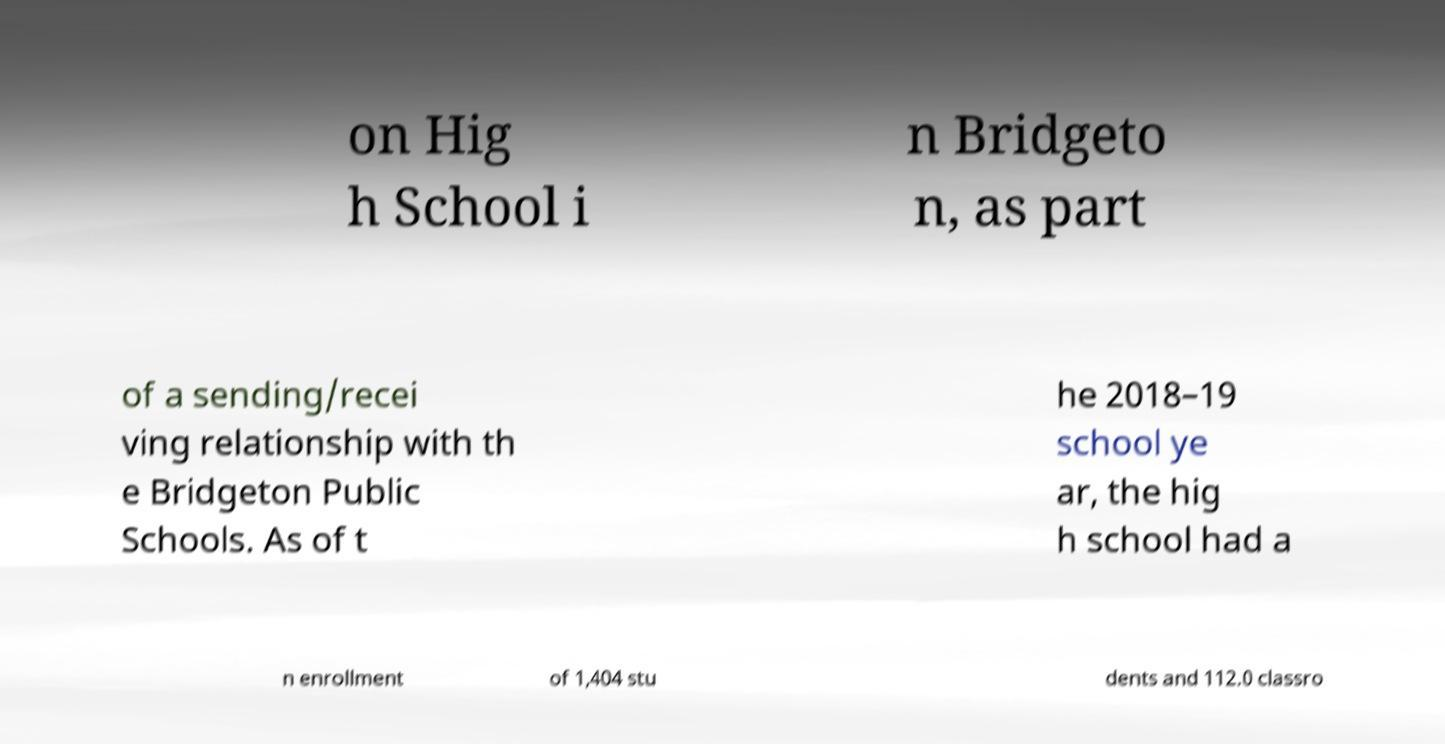Could you extract and type out the text from this image? on Hig h School i n Bridgeto n, as part of a sending/recei ving relationship with th e Bridgeton Public Schools. As of t he 2018–19 school ye ar, the hig h school had a n enrollment of 1,404 stu dents and 112.0 classro 